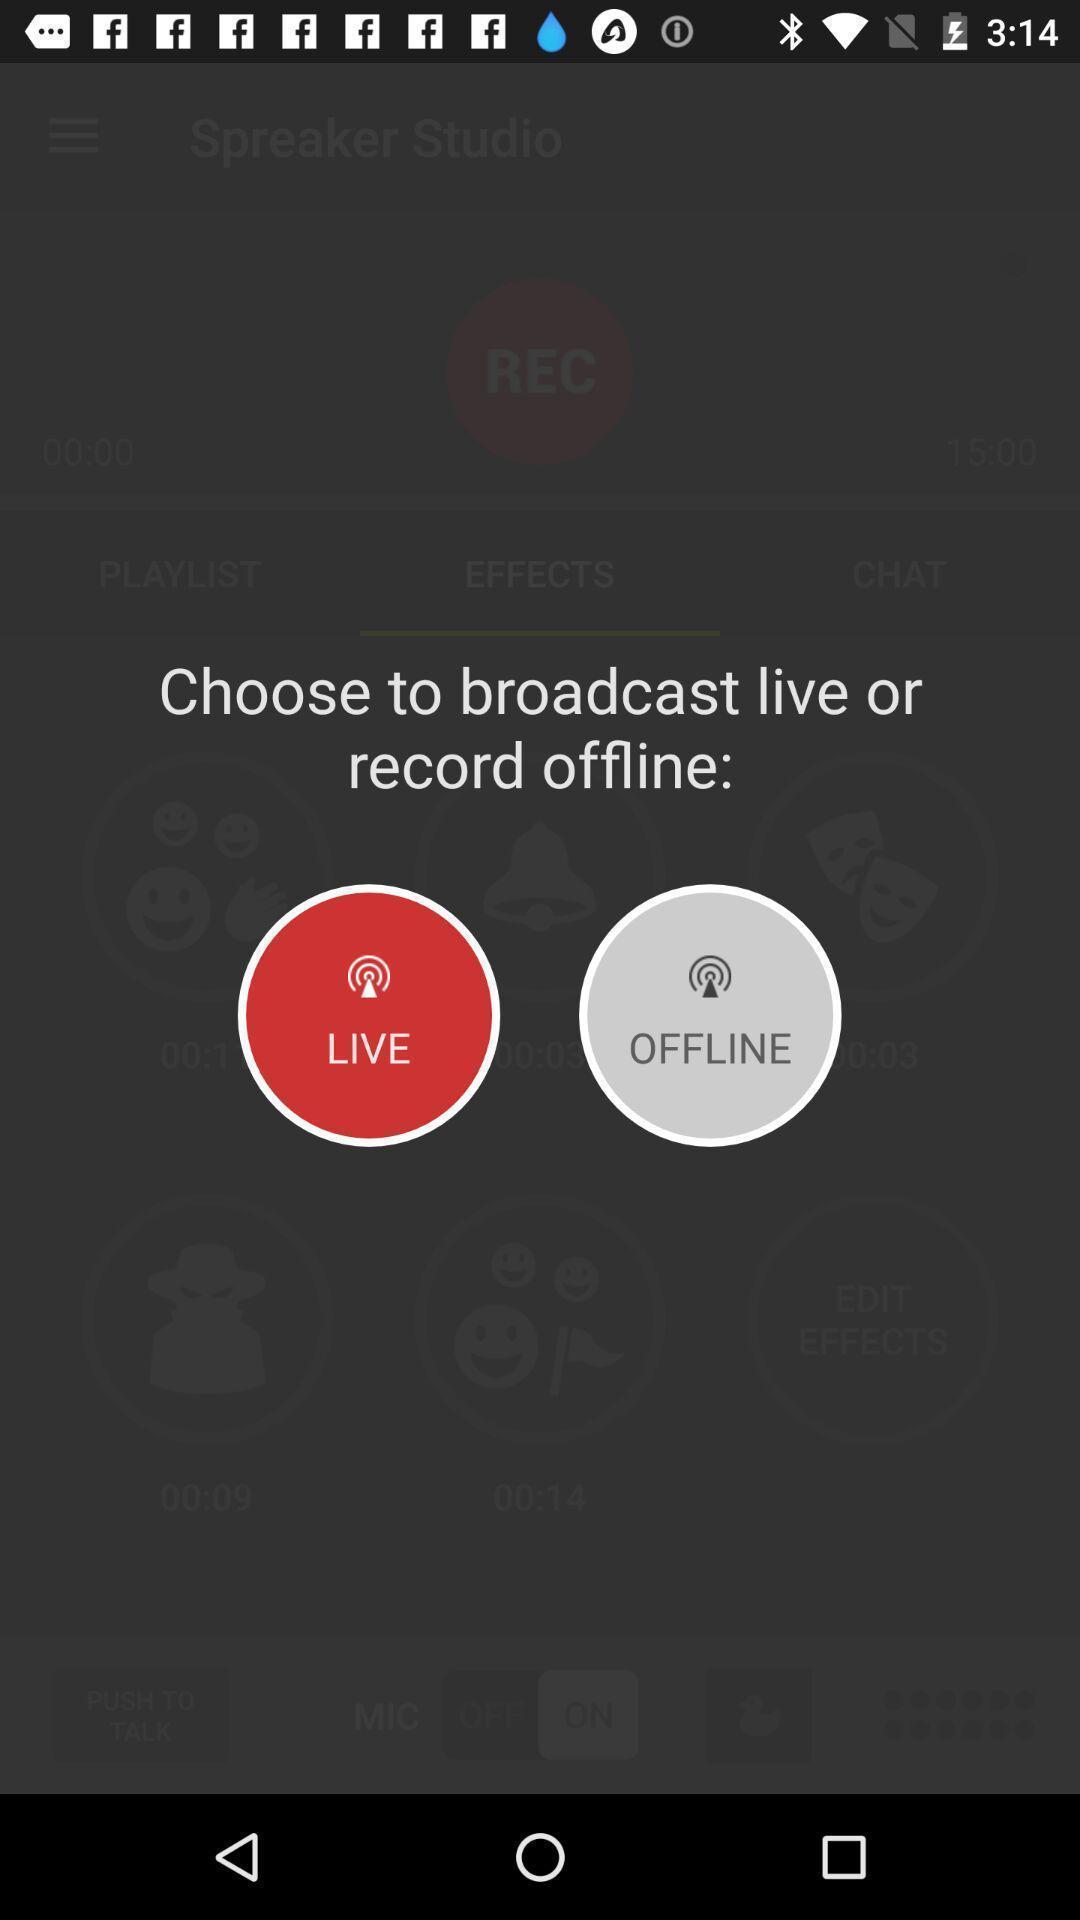Give me a narrative description of this picture. Page displaying two options with some text in service app. 